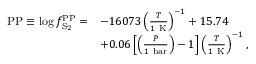<formula> <loc_0><loc_0><loc_500><loc_500>\begin{array} { r l } { { P P } \equiv \log f _ { S _ { 2 } } ^ { P P } = } & { - 1 6 0 7 3 \left ( \frac { T } { 1 K } \right ) ^ { - 1 } + 1 5 . 7 4 } \\ & { + 0 . 0 6 \left [ \left ( \frac { P } { 1 b a r } \right ) - 1 \right ] \left ( \frac { T } { 1 K } \right ) ^ { - 1 } , } \end{array}</formula> 